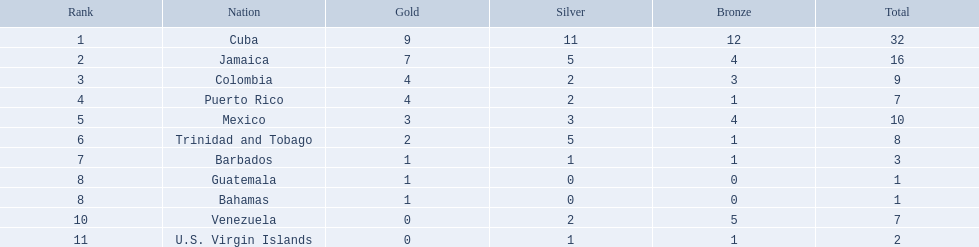In the 1966 central american and caribbean games, which nations participated? Cuba, Jamaica, Colombia, Puerto Rico, Mexico, Trinidad and Tobago, Barbados, Guatemala, Bahamas, Venezuela, U.S. Virgin Islands. Which of these nations secured a minimum of six silver medals? Cuba. 